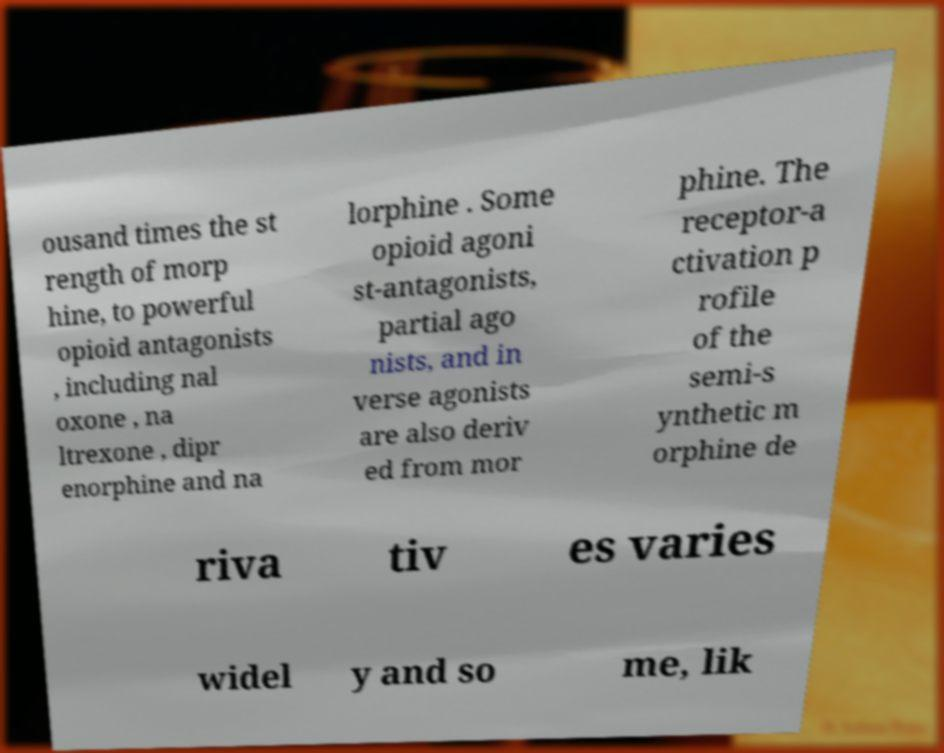Could you extract and type out the text from this image? ousand times the st rength of morp hine, to powerful opioid antagonists , including nal oxone , na ltrexone , dipr enorphine and na lorphine . Some opioid agoni st-antagonists, partial ago nists, and in verse agonists are also deriv ed from mor phine. The receptor-a ctivation p rofile of the semi-s ynthetic m orphine de riva tiv es varies widel y and so me, lik 